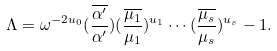Convert formula to latex. <formula><loc_0><loc_0><loc_500><loc_500>\Lambda = \omega ^ { - 2 u _ { 0 } } ( \frac { \overline { \alpha ^ { \prime } } } { \alpha ^ { \prime } } ) ( \frac { \overline { \mu _ { 1 } } } { \mu _ { 1 } } ) ^ { u _ { 1 } } \cdots ( \frac { \overline { \mu _ { s } } } { \mu _ { s } } ) ^ { u _ { s } } - 1 .</formula> 